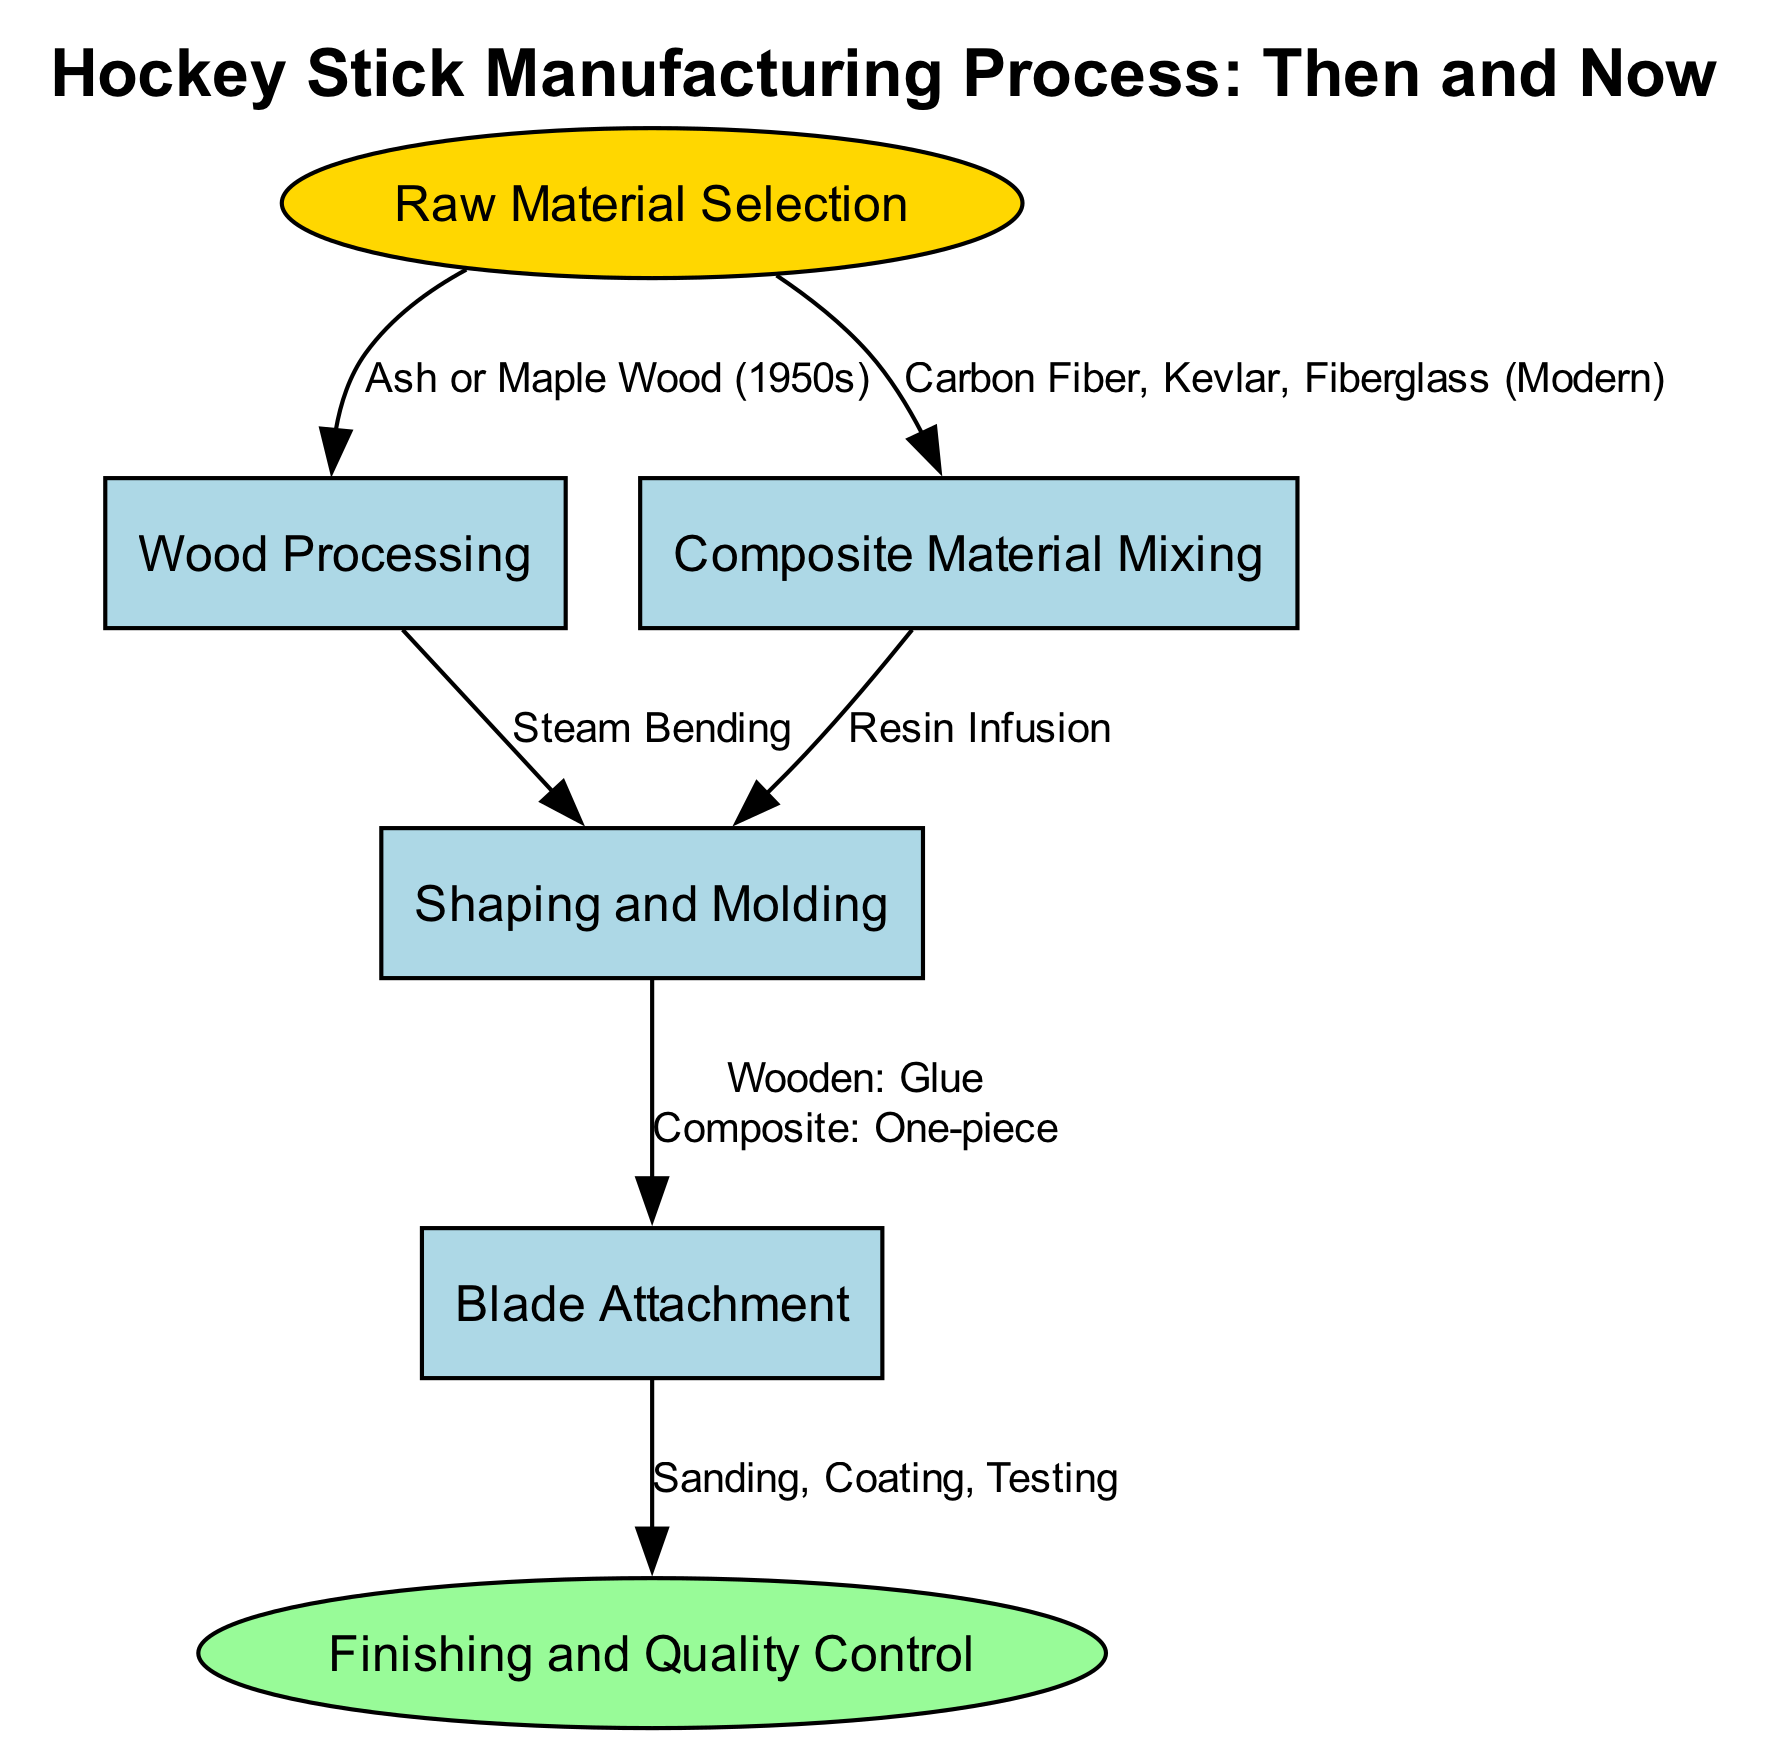What is the first step in the manufacturing process? The diagram starts with the "Raw Material Selection" node, which is the initial step of the process.
Answer: Raw Material Selection How many nodes are in the diagram? The total number of nodes listed in the diagram is six, indicating the various stages involved in manufacturing a hockey stick.
Answer: 6 What materials are selected in the modern manufacturing process? The diagram specifies "Carbon Fiber, Kevlar, Fiberglass" as the composite materials chosen in the modern manufacturing process, shown in the edge connecting Raw Material Selection to Composite Material Mixing.
Answer: Carbon Fiber, Kevlar, Fiberglass What type of wood is used in the 1950s process? According to the edge from Raw Material Selection to Wood Processing, "Ash or Maple Wood" is identified as the materials used during the 1950s.
Answer: Ash or Maple Wood What process is used after wood processing? The diagram depicts that after the "Wood Processing" step, the next step is "Shaping and Molding," showing the continuity of the manufacturing steps.
Answer: Shaping and Molding Which manufacturing method is associated with the attachment of the blade? The edge between the Shaping and Molding and Blade Attachment nodes indicates that the attachment method varies: "Wooden: Glue" for wooden sticks and "Composite: One-piece" for composite sticks.
Answer: Wooden: Glue, Composite: One-piece What is the final step in the manufacturing process? The final step, labeled "Finishing and Quality Control," is connected to the Blade Attachment process, indicating that finishing touches and quality checks are the concluding phase.
Answer: Finishing and Quality Control Which material processing method is specific to composite materials? The diagram shows "Resin Infusion" as the specific material processing method utilized after composite material mixing, suggesting its role in creating composite hockey sticks.
Answer: Resin Infusion How do the traditional and modern processes differ in raw material selection? The comparison is illustrated in the diagram: traditional processes select "Ash or Maple Wood," while modern processes choose "Carbon Fiber, Kevlar, Fiberglass," highlighting the evolution in materials over time.
Answer: Ash or Maple Wood, Carbon Fiber, Kevlar, Fiberglass 